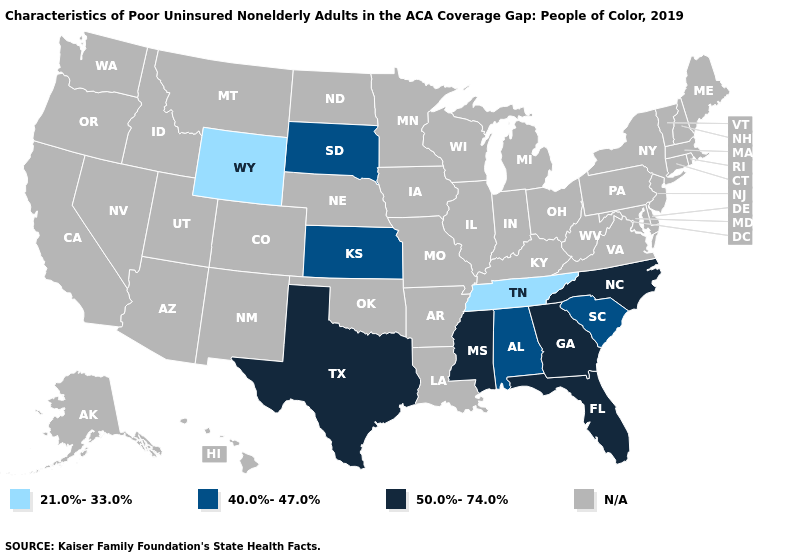Among the states that border Iowa , which have the highest value?
Keep it brief. South Dakota. Is the legend a continuous bar?
Short answer required. No. What is the value of Mississippi?
Answer briefly. 50.0%-74.0%. Which states have the lowest value in the South?
Quick response, please. Tennessee. Name the states that have a value in the range 40.0%-47.0%?
Be succinct. Alabama, Kansas, South Carolina, South Dakota. What is the highest value in the West ?
Concise answer only. 21.0%-33.0%. Name the states that have a value in the range 21.0%-33.0%?
Answer briefly. Tennessee, Wyoming. Is the legend a continuous bar?
Concise answer only. No. What is the highest value in states that border Tennessee?
Write a very short answer. 50.0%-74.0%. Among the states that border Utah , which have the lowest value?
Answer briefly. Wyoming. 